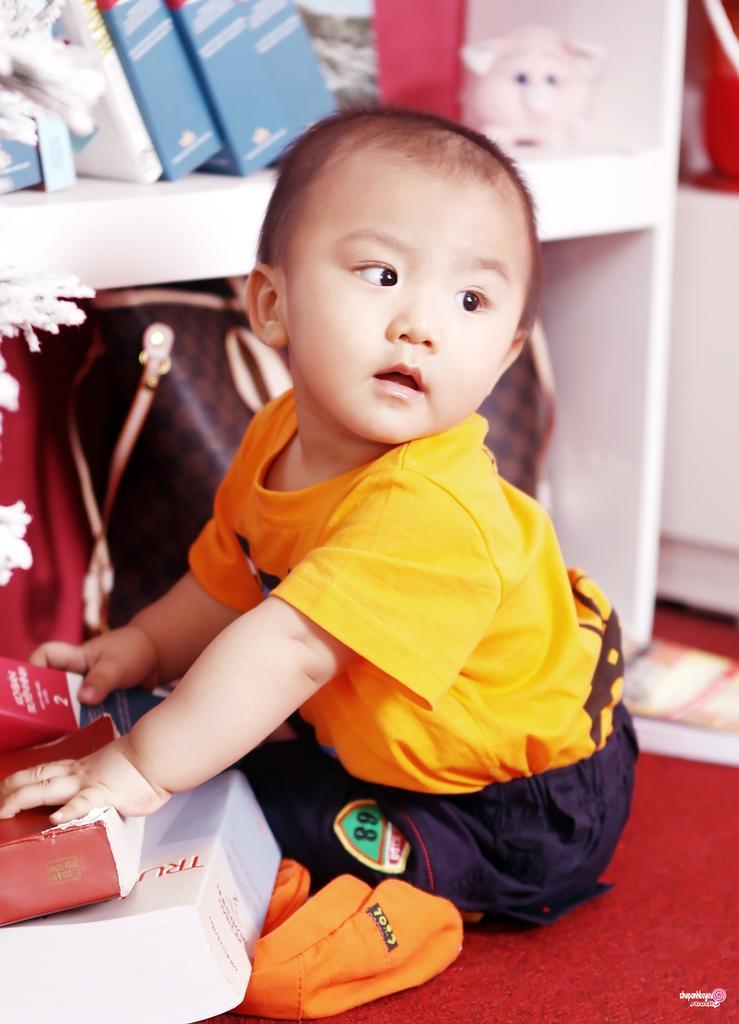Describe this image in one or two sentences. In this image in the front there is a boy sitting and holding books. In the background there is a shelf and in the shelf there are books and there are purses. 